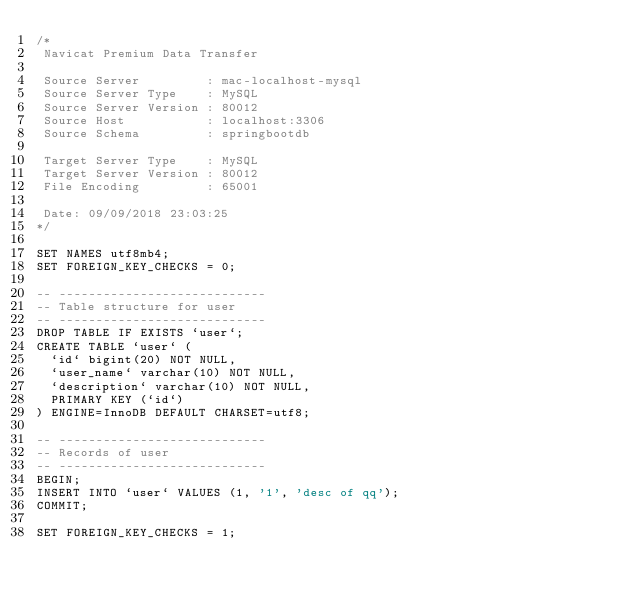<code> <loc_0><loc_0><loc_500><loc_500><_SQL_>/*
 Navicat Premium Data Transfer

 Source Server         : mac-localhost-mysql
 Source Server Type    : MySQL
 Source Server Version : 80012
 Source Host           : localhost:3306
 Source Schema         : springbootdb

 Target Server Type    : MySQL
 Target Server Version : 80012
 File Encoding         : 65001

 Date: 09/09/2018 23:03:25
*/

SET NAMES utf8mb4;
SET FOREIGN_KEY_CHECKS = 0;

-- ----------------------------
-- Table structure for user
-- ----------------------------
DROP TABLE IF EXISTS `user`;
CREATE TABLE `user` (
  `id` bigint(20) NOT NULL,
  `user_name` varchar(10) NOT NULL,
  `description` varchar(10) NOT NULL,
  PRIMARY KEY (`id`)
) ENGINE=InnoDB DEFAULT CHARSET=utf8;

-- ----------------------------
-- Records of user
-- ----------------------------
BEGIN;
INSERT INTO `user` VALUES (1, '1', 'desc of qq');
COMMIT;

SET FOREIGN_KEY_CHECKS = 1;
</code> 